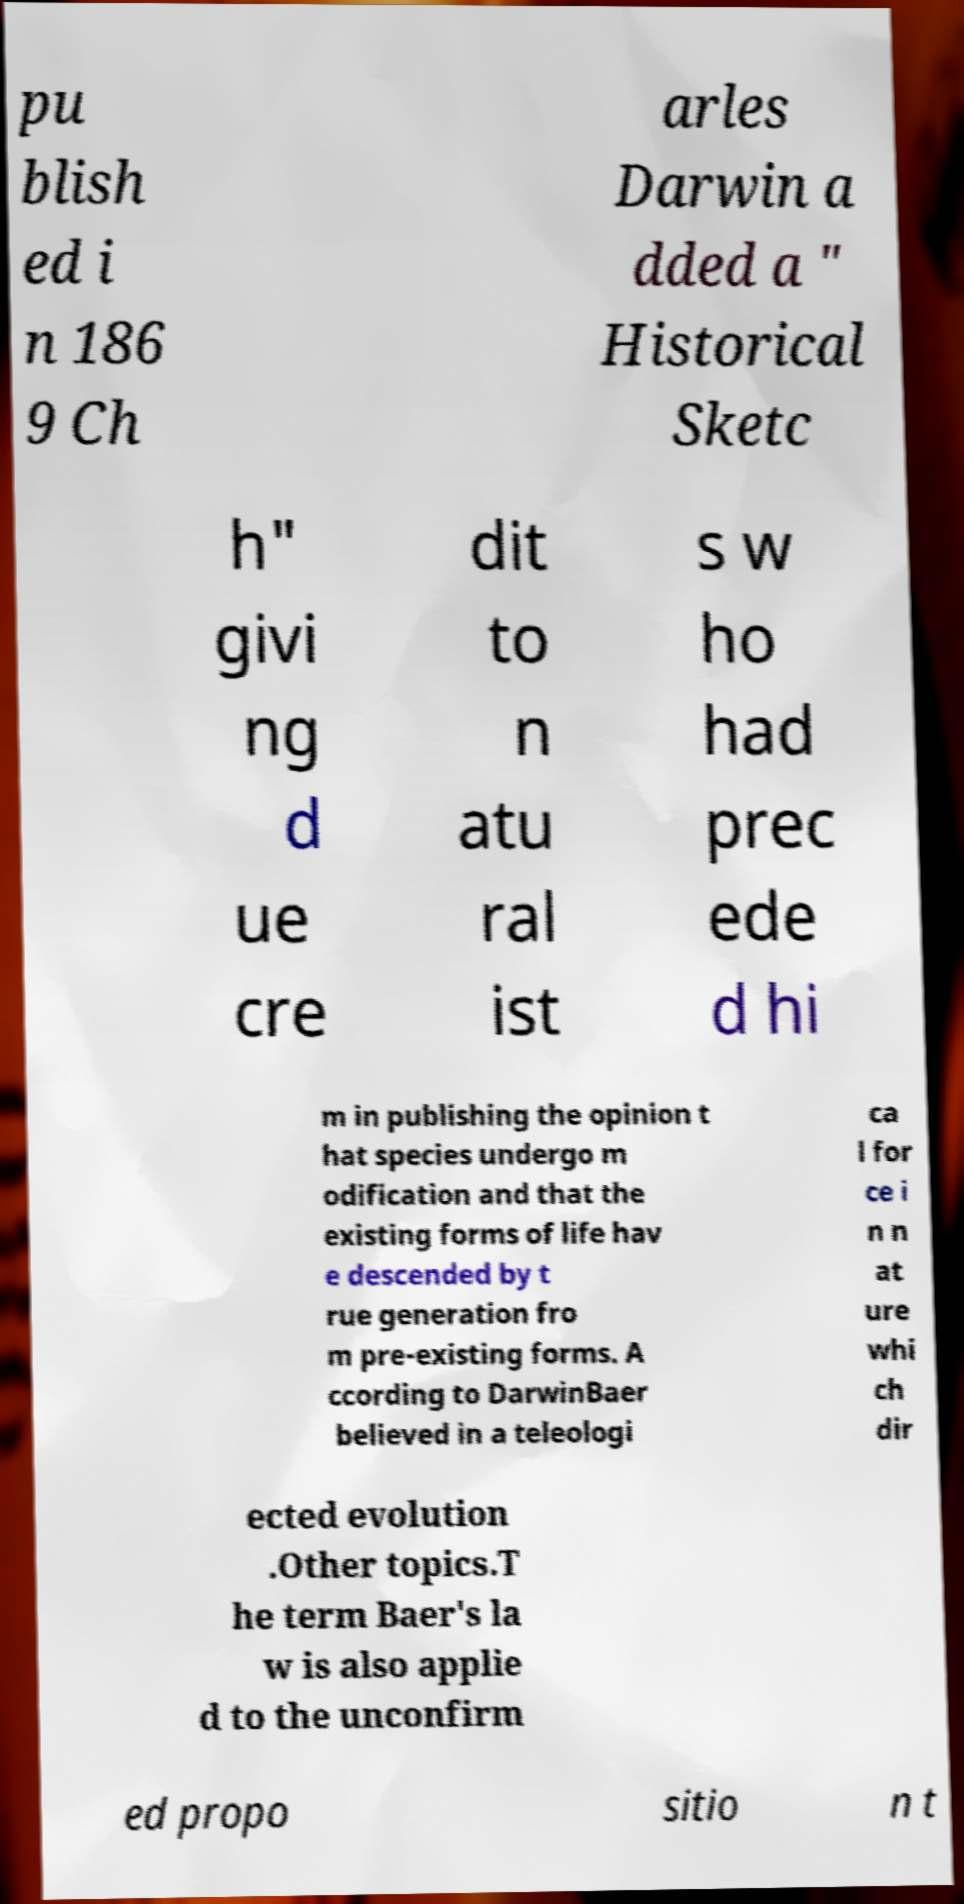There's text embedded in this image that I need extracted. Can you transcribe it verbatim? pu blish ed i n 186 9 Ch arles Darwin a dded a " Historical Sketc h" givi ng d ue cre dit to n atu ral ist s w ho had prec ede d hi m in publishing the opinion t hat species undergo m odification and that the existing forms of life hav e descended by t rue generation fro m pre-existing forms. A ccording to DarwinBaer believed in a teleologi ca l for ce i n n at ure whi ch dir ected evolution .Other topics.T he term Baer's la w is also applie d to the unconfirm ed propo sitio n t 